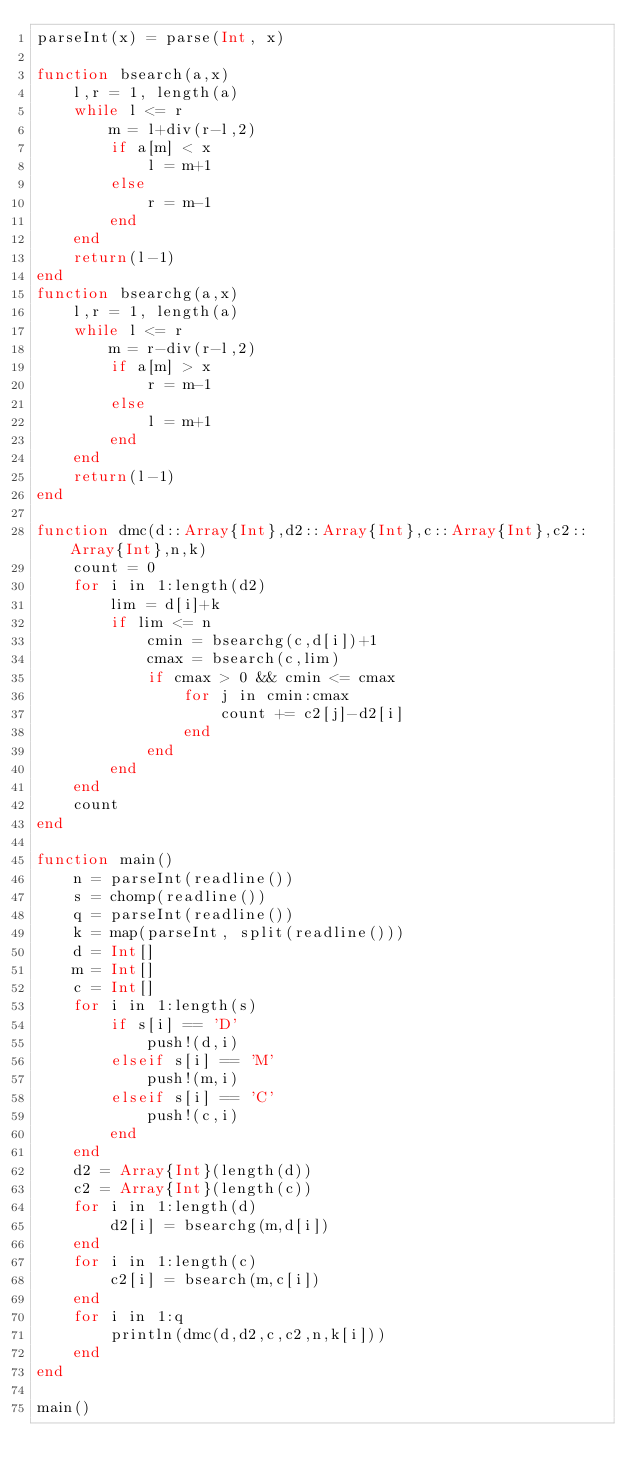<code> <loc_0><loc_0><loc_500><loc_500><_Julia_>parseInt(x) = parse(Int, x)

function bsearch(a,x)
	l,r = 1, length(a)
	while l <= r
		m = l+div(r-l,2)
		if a[m] < x
			l = m+1
		else
			r = m-1
		end
	end
	return(l-1)
end
function bsearchg(a,x)
	l,r = 1, length(a)
	while l <= r
		m = r-div(r-l,2)
		if a[m] > x
			r = m-1
		else
			l = m+1
		end
	end
	return(l-1)
end

function dmc(d::Array{Int},d2::Array{Int},c::Array{Int},c2::Array{Int},n,k)
	count = 0
	for i in 1:length(d2)
		lim = d[i]+k
		if lim <= n
			cmin = bsearchg(c,d[i])+1
			cmax = bsearch(c,lim)
			if cmax > 0 && cmin <= cmax
				for j in cmin:cmax
					count += c2[j]-d2[i]
				end
			end
		end
	end
	count
end

function main()
	n = parseInt(readline())
	s = chomp(readline())
	q = parseInt(readline())
	k = map(parseInt, split(readline()))
	d = Int[]
	m = Int[]
	c = Int[]
	for i in 1:length(s)
		if s[i] == 'D'
			push!(d,i)
		elseif s[i] == 'M'
			push!(m,i)
		elseif s[i] == 'C'
			push!(c,i)
		end
	end
	d2 = Array{Int}(length(d))
	c2 = Array{Int}(length(c))
	for i in 1:length(d)
		d2[i] = bsearchg(m,d[i])
	end
	for i in 1:length(c)
		c2[i] = bsearch(m,c[i])
	end
	for i in 1:q
		println(dmc(d,d2,c,c2,n,k[i]))
	end
end

main()</code> 